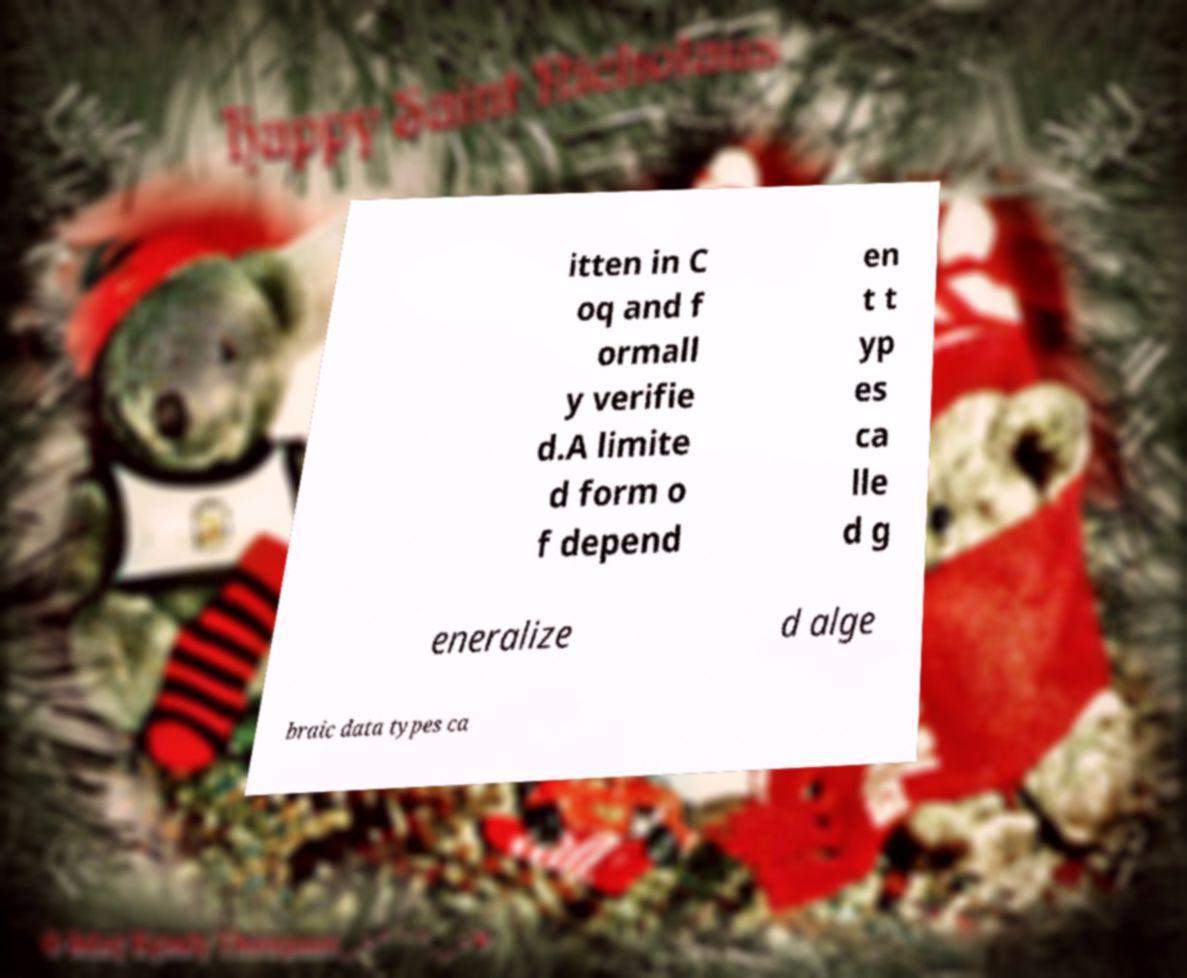Please identify and transcribe the text found in this image. itten in C oq and f ormall y verifie d.A limite d form o f depend en t t yp es ca lle d g eneralize d alge braic data types ca 